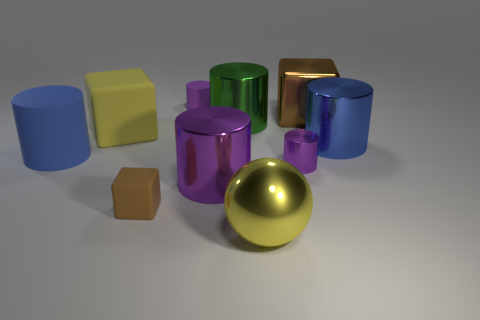How many other objects are there of the same material as the tiny cube?
Provide a short and direct response. 3. Is the blue rubber cylinder the same size as the brown metal block?
Your answer should be compact. Yes. What is the shape of the large metallic object to the left of the big green cylinder?
Make the answer very short. Cylinder. There is a rubber block to the left of the tiny object to the left of the purple rubber thing; what color is it?
Ensure brevity in your answer.  Yellow. There is a thing that is left of the yellow cube; does it have the same shape as the shiny thing right of the brown metal block?
Ensure brevity in your answer.  Yes. The rubber object that is the same size as the brown rubber cube is what shape?
Offer a terse response. Cylinder. What color is the cube that is the same material as the green object?
Provide a succinct answer. Brown. There is a yellow rubber object; does it have the same shape as the purple metal object that is right of the big purple shiny object?
Your answer should be compact. No. What material is the small object that is the same color as the tiny matte cylinder?
Give a very brief answer. Metal. There is a purple thing that is the same size as the blue matte cylinder; what is it made of?
Provide a short and direct response. Metal. 